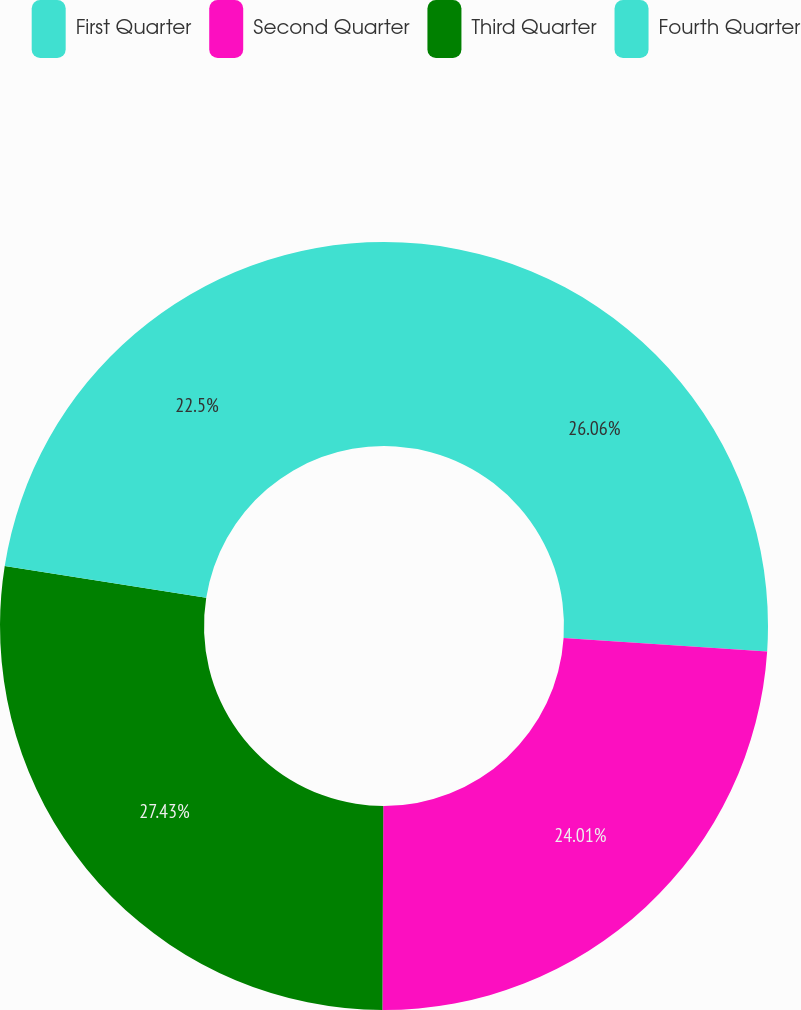Convert chart. <chart><loc_0><loc_0><loc_500><loc_500><pie_chart><fcel>First Quarter<fcel>Second Quarter<fcel>Third Quarter<fcel>Fourth Quarter<nl><fcel>26.06%<fcel>24.01%<fcel>27.44%<fcel>22.5%<nl></chart> 